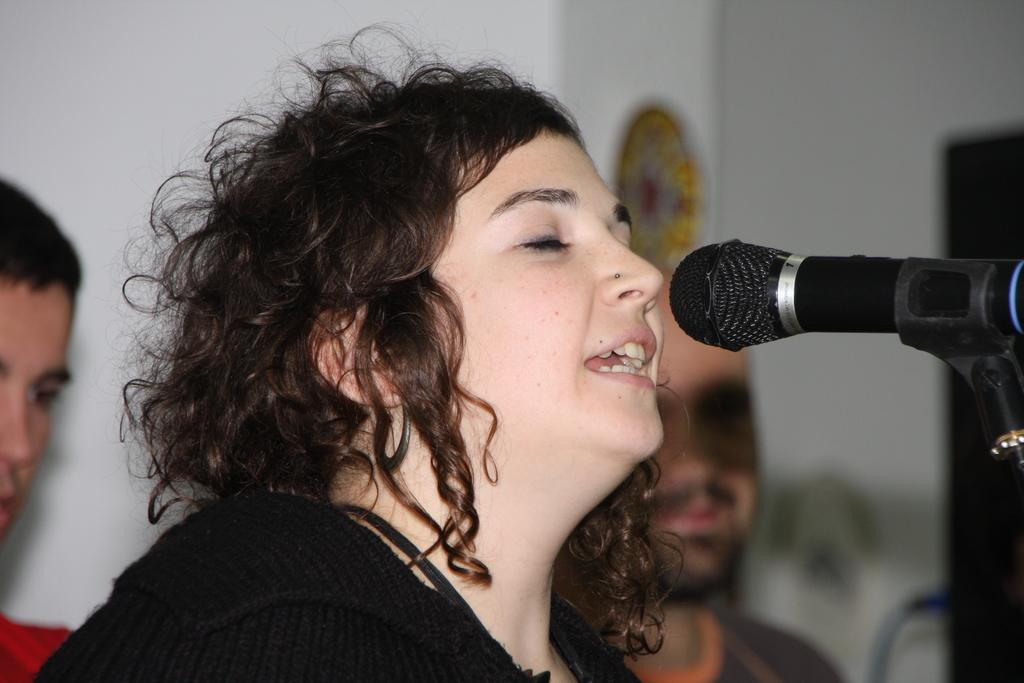How many people are present in the image? There are three people in the image. Can you describe the woman in the foreground? The woman is in the foreground, and she is in front of a microphone. What is visible behind the people in the image? There is a wall behind the people in the image. What type of animals can be seen in the zoo in the image? There is no zoo present in the image, so it is not possible to determine what type of animals might be seen. 